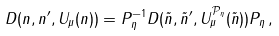<formula> <loc_0><loc_0><loc_500><loc_500>D ( n , n ^ { \prime } , U _ { \mu } ( n ) ) = P _ { \eta } ^ { - 1 } D ( \tilde { n } , \tilde { n } ^ { \prime } , U _ { \mu } ^ { \mathcal { P } _ { \eta } } ( \tilde { n } ) ) P _ { \eta } \, ,</formula> 